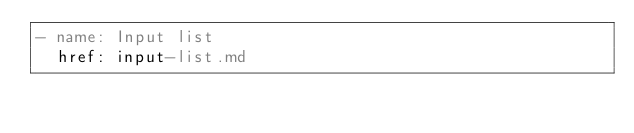<code> <loc_0><loc_0><loc_500><loc_500><_YAML_>- name: Input list
  href: input-list.md</code> 